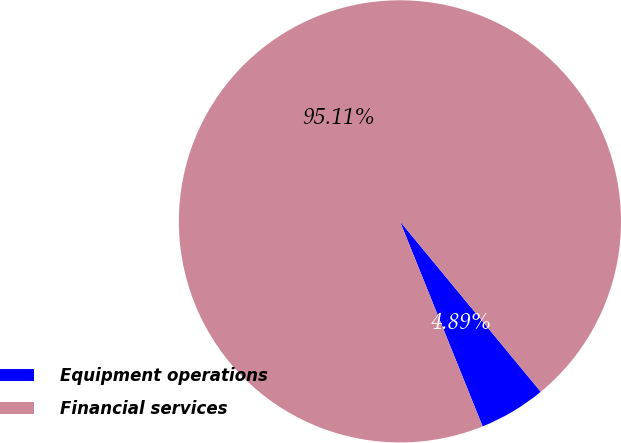Convert chart. <chart><loc_0><loc_0><loc_500><loc_500><pie_chart><fcel>Equipment operations<fcel>Financial services<nl><fcel>4.89%<fcel>95.11%<nl></chart> 